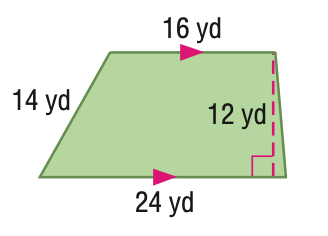Question: Find the area of the quadrilateral.
Choices:
A. 168
B. 192
C. 240
D. 288
Answer with the letter. Answer: C 